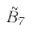<formula> <loc_0><loc_0><loc_500><loc_500>\tilde { B } _ { 7 }</formula> 